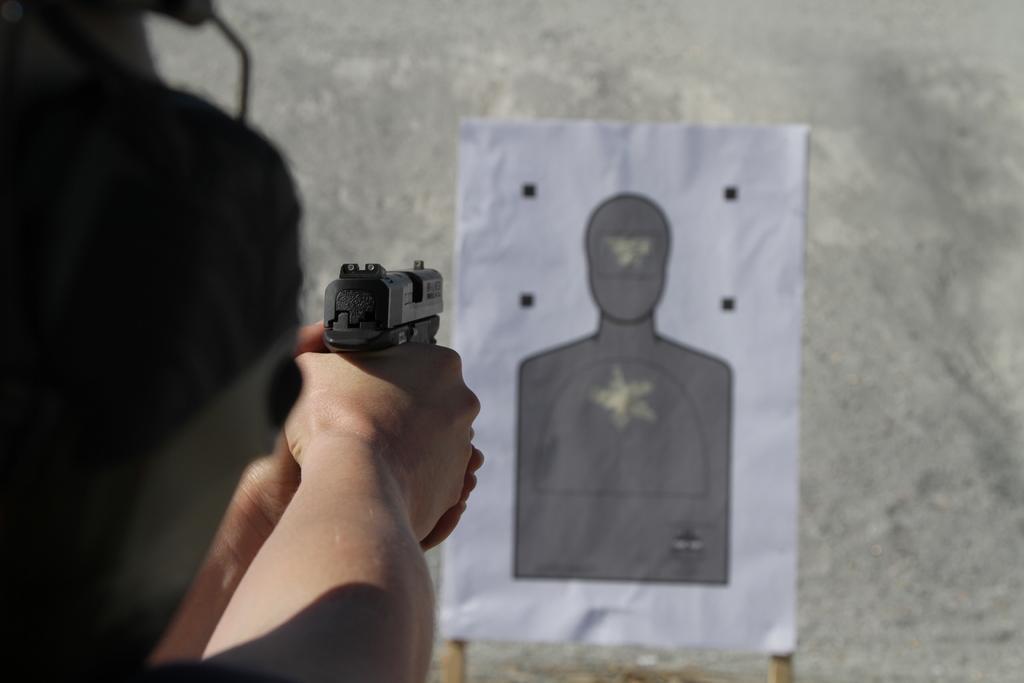Please provide a concise description of this image. On the left there is a person holding a gun in his hands and aiming towards a board over here and on the board we can see a figure. In the background we can see a wall. 